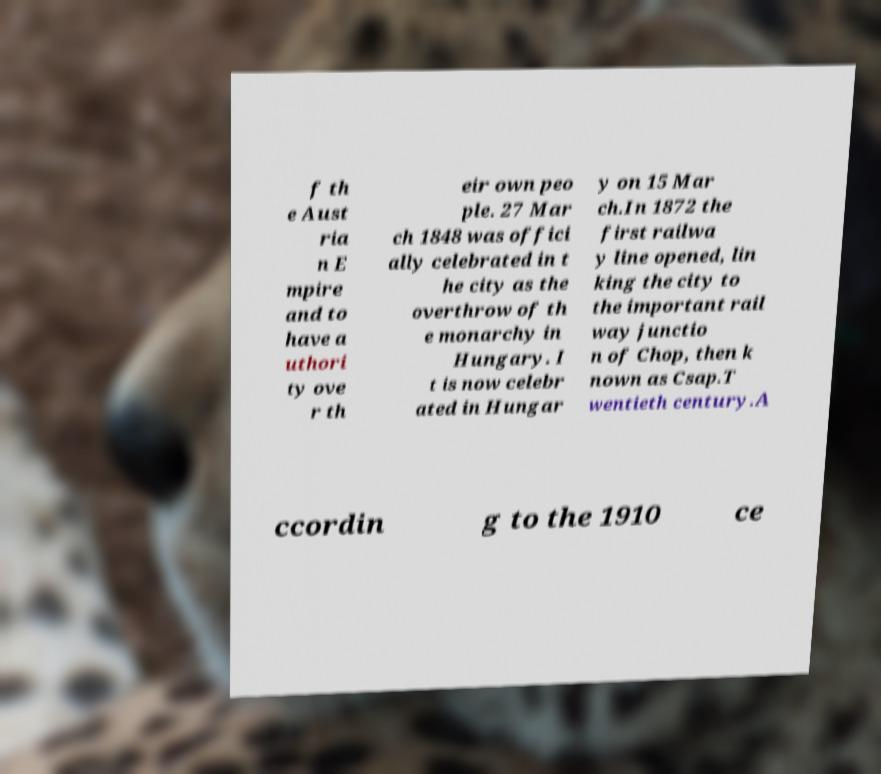What messages or text are displayed in this image? I need them in a readable, typed format. f th e Aust ria n E mpire and to have a uthori ty ove r th eir own peo ple. 27 Mar ch 1848 was offici ally celebrated in t he city as the overthrow of th e monarchy in Hungary. I t is now celebr ated in Hungar y on 15 Mar ch.In 1872 the first railwa y line opened, lin king the city to the important rail way junctio n of Chop, then k nown as Csap.T wentieth century.A ccordin g to the 1910 ce 